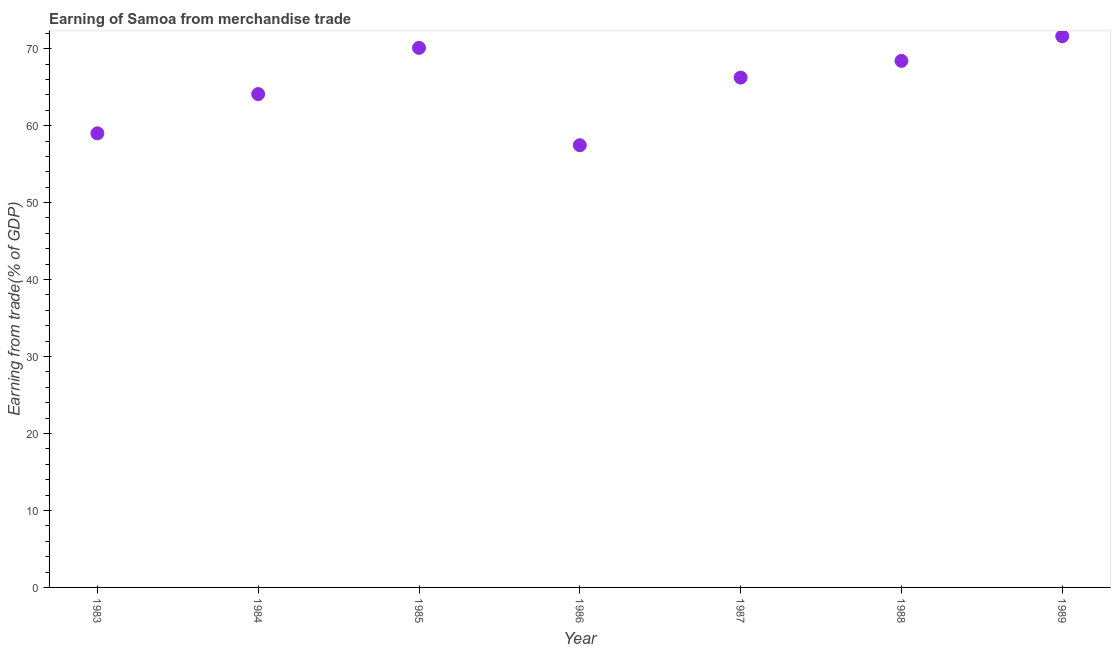What is the earning from merchandise trade in 1989?
Offer a terse response. 71.61. Across all years, what is the maximum earning from merchandise trade?
Provide a succinct answer. 71.61. Across all years, what is the minimum earning from merchandise trade?
Make the answer very short. 57.45. In which year was the earning from merchandise trade maximum?
Your answer should be very brief. 1989. What is the sum of the earning from merchandise trade?
Give a very brief answer. 456.92. What is the difference between the earning from merchandise trade in 1985 and 1986?
Keep it short and to the point. 12.65. What is the average earning from merchandise trade per year?
Offer a very short reply. 65.27. What is the median earning from merchandise trade?
Offer a very short reply. 66.24. In how many years, is the earning from merchandise trade greater than 40 %?
Your answer should be compact. 7. What is the ratio of the earning from merchandise trade in 1986 to that in 1988?
Offer a very short reply. 0.84. Is the earning from merchandise trade in 1985 less than that in 1989?
Give a very brief answer. Yes. Is the difference between the earning from merchandise trade in 1986 and 1987 greater than the difference between any two years?
Give a very brief answer. No. What is the difference between the highest and the second highest earning from merchandise trade?
Offer a terse response. 1.51. Is the sum of the earning from merchandise trade in 1986 and 1987 greater than the maximum earning from merchandise trade across all years?
Keep it short and to the point. Yes. What is the difference between the highest and the lowest earning from merchandise trade?
Your answer should be compact. 14.16. In how many years, is the earning from merchandise trade greater than the average earning from merchandise trade taken over all years?
Make the answer very short. 4. How many years are there in the graph?
Offer a terse response. 7. Are the values on the major ticks of Y-axis written in scientific E-notation?
Offer a very short reply. No. Does the graph contain grids?
Offer a terse response. No. What is the title of the graph?
Keep it short and to the point. Earning of Samoa from merchandise trade. What is the label or title of the X-axis?
Give a very brief answer. Year. What is the label or title of the Y-axis?
Your answer should be very brief. Earning from trade(% of GDP). What is the Earning from trade(% of GDP) in 1983?
Offer a very short reply. 59. What is the Earning from trade(% of GDP) in 1984?
Offer a very short reply. 64.1. What is the Earning from trade(% of GDP) in 1985?
Make the answer very short. 70.1. What is the Earning from trade(% of GDP) in 1986?
Keep it short and to the point. 57.45. What is the Earning from trade(% of GDP) in 1987?
Your answer should be very brief. 66.24. What is the Earning from trade(% of GDP) in 1988?
Offer a terse response. 68.41. What is the Earning from trade(% of GDP) in 1989?
Keep it short and to the point. 71.61. What is the difference between the Earning from trade(% of GDP) in 1983 and 1984?
Your answer should be compact. -5.1. What is the difference between the Earning from trade(% of GDP) in 1983 and 1985?
Your answer should be compact. -11.1. What is the difference between the Earning from trade(% of GDP) in 1983 and 1986?
Provide a short and direct response. 1.55. What is the difference between the Earning from trade(% of GDP) in 1983 and 1987?
Your response must be concise. -7.24. What is the difference between the Earning from trade(% of GDP) in 1983 and 1988?
Keep it short and to the point. -9.41. What is the difference between the Earning from trade(% of GDP) in 1983 and 1989?
Offer a very short reply. -12.61. What is the difference between the Earning from trade(% of GDP) in 1984 and 1985?
Ensure brevity in your answer.  -6. What is the difference between the Earning from trade(% of GDP) in 1984 and 1986?
Provide a succinct answer. 6.65. What is the difference between the Earning from trade(% of GDP) in 1984 and 1987?
Keep it short and to the point. -2.14. What is the difference between the Earning from trade(% of GDP) in 1984 and 1988?
Offer a terse response. -4.31. What is the difference between the Earning from trade(% of GDP) in 1984 and 1989?
Your response must be concise. -7.51. What is the difference between the Earning from trade(% of GDP) in 1985 and 1986?
Give a very brief answer. 12.65. What is the difference between the Earning from trade(% of GDP) in 1985 and 1987?
Offer a very short reply. 3.86. What is the difference between the Earning from trade(% of GDP) in 1985 and 1988?
Keep it short and to the point. 1.69. What is the difference between the Earning from trade(% of GDP) in 1985 and 1989?
Provide a short and direct response. -1.51. What is the difference between the Earning from trade(% of GDP) in 1986 and 1987?
Your response must be concise. -8.78. What is the difference between the Earning from trade(% of GDP) in 1986 and 1988?
Make the answer very short. -10.96. What is the difference between the Earning from trade(% of GDP) in 1986 and 1989?
Your answer should be very brief. -14.16. What is the difference between the Earning from trade(% of GDP) in 1987 and 1988?
Ensure brevity in your answer.  -2.17. What is the difference between the Earning from trade(% of GDP) in 1987 and 1989?
Offer a terse response. -5.37. What is the difference between the Earning from trade(% of GDP) in 1988 and 1989?
Give a very brief answer. -3.2. What is the ratio of the Earning from trade(% of GDP) in 1983 to that in 1984?
Provide a short and direct response. 0.92. What is the ratio of the Earning from trade(% of GDP) in 1983 to that in 1985?
Provide a short and direct response. 0.84. What is the ratio of the Earning from trade(% of GDP) in 1983 to that in 1987?
Offer a terse response. 0.89. What is the ratio of the Earning from trade(% of GDP) in 1983 to that in 1988?
Offer a terse response. 0.86. What is the ratio of the Earning from trade(% of GDP) in 1983 to that in 1989?
Offer a very short reply. 0.82. What is the ratio of the Earning from trade(% of GDP) in 1984 to that in 1985?
Your answer should be compact. 0.91. What is the ratio of the Earning from trade(% of GDP) in 1984 to that in 1986?
Your response must be concise. 1.12. What is the ratio of the Earning from trade(% of GDP) in 1984 to that in 1987?
Give a very brief answer. 0.97. What is the ratio of the Earning from trade(% of GDP) in 1984 to that in 1988?
Your answer should be compact. 0.94. What is the ratio of the Earning from trade(% of GDP) in 1984 to that in 1989?
Offer a terse response. 0.9. What is the ratio of the Earning from trade(% of GDP) in 1985 to that in 1986?
Give a very brief answer. 1.22. What is the ratio of the Earning from trade(% of GDP) in 1985 to that in 1987?
Give a very brief answer. 1.06. What is the ratio of the Earning from trade(% of GDP) in 1985 to that in 1988?
Your response must be concise. 1.02. What is the ratio of the Earning from trade(% of GDP) in 1985 to that in 1989?
Your answer should be compact. 0.98. What is the ratio of the Earning from trade(% of GDP) in 1986 to that in 1987?
Your answer should be very brief. 0.87. What is the ratio of the Earning from trade(% of GDP) in 1986 to that in 1988?
Your response must be concise. 0.84. What is the ratio of the Earning from trade(% of GDP) in 1986 to that in 1989?
Your response must be concise. 0.8. What is the ratio of the Earning from trade(% of GDP) in 1987 to that in 1989?
Ensure brevity in your answer.  0.93. What is the ratio of the Earning from trade(% of GDP) in 1988 to that in 1989?
Ensure brevity in your answer.  0.95. 